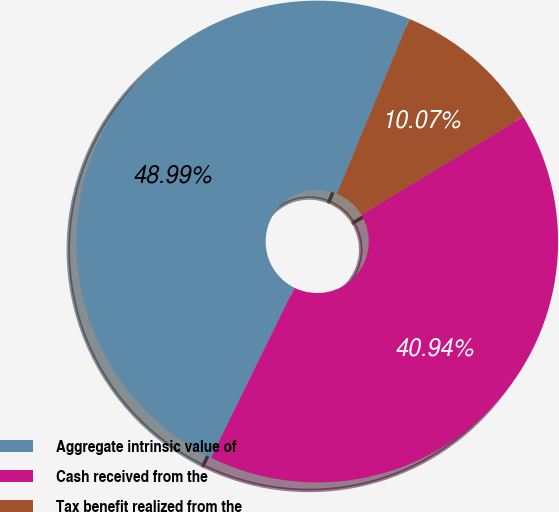Convert chart to OTSL. <chart><loc_0><loc_0><loc_500><loc_500><pie_chart><fcel>Aggregate intrinsic value of<fcel>Cash received from the<fcel>Tax benefit realized from the<nl><fcel>48.99%<fcel>40.94%<fcel>10.07%<nl></chart> 